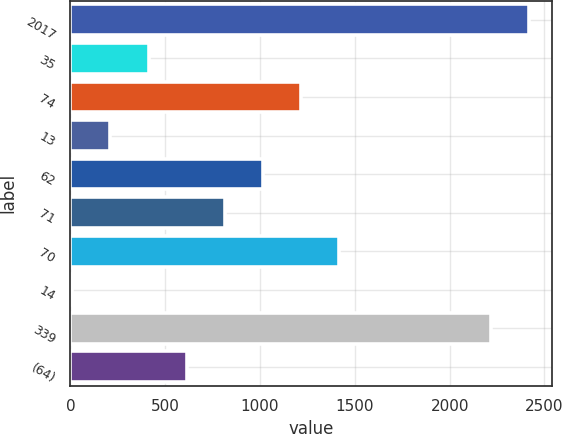Convert chart. <chart><loc_0><loc_0><loc_500><loc_500><bar_chart><fcel>2017<fcel>35<fcel>74<fcel>13<fcel>62<fcel>71<fcel>70<fcel>14<fcel>339<fcel>(64)<nl><fcel>2417<fcel>412<fcel>1214<fcel>211.5<fcel>1013.5<fcel>813<fcel>1414.5<fcel>11<fcel>2216.5<fcel>612.5<nl></chart> 